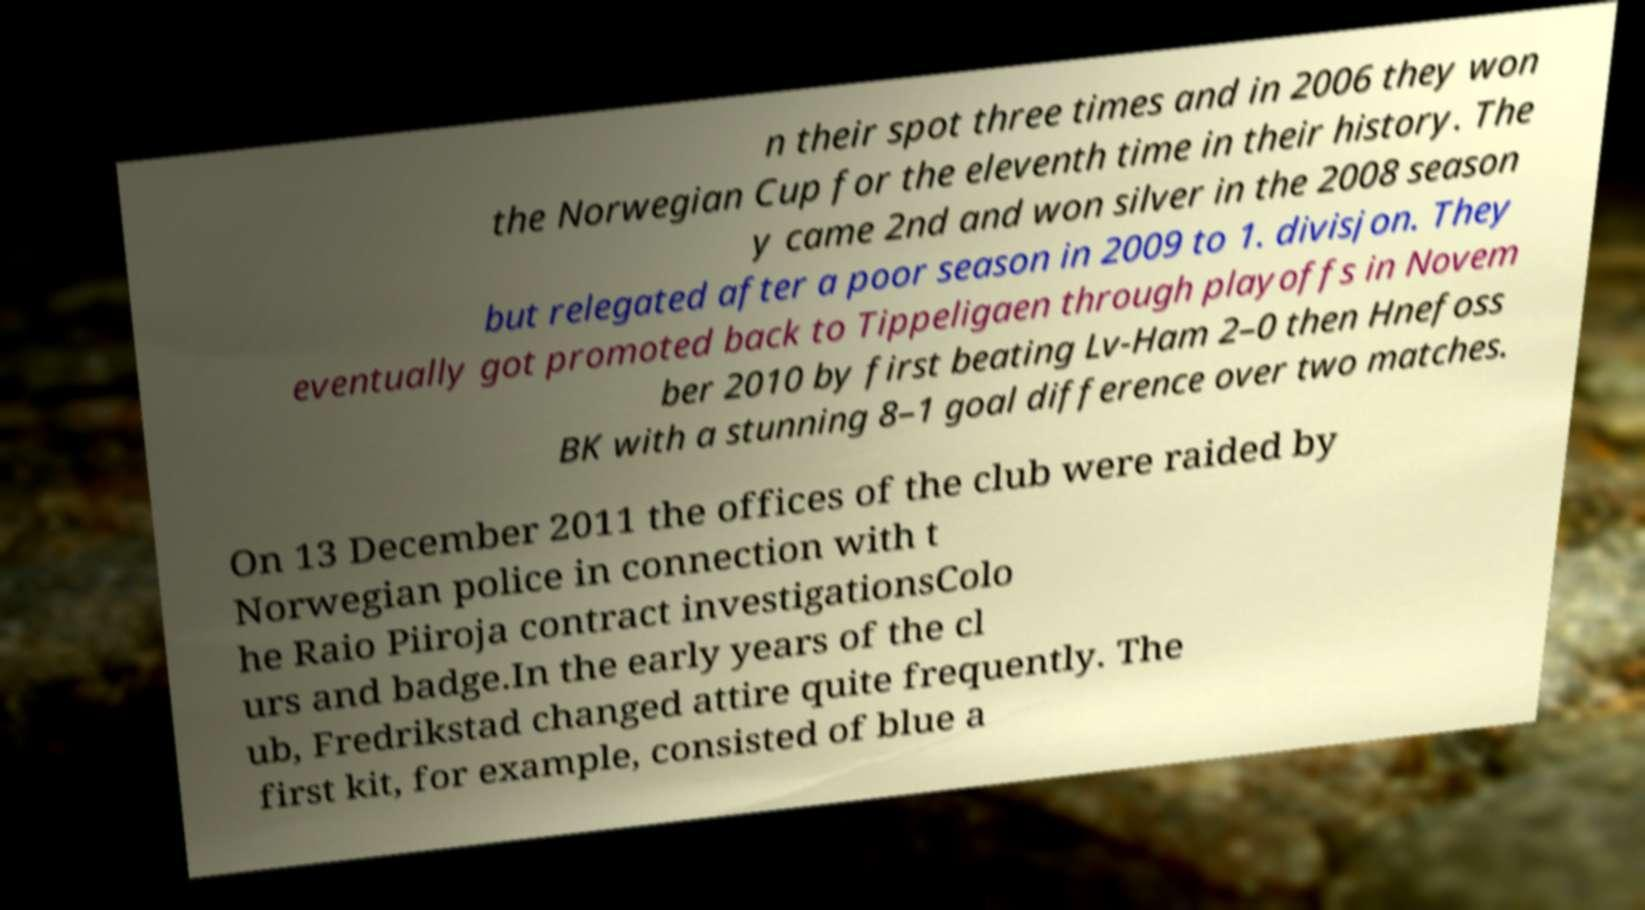Can you read and provide the text displayed in the image?This photo seems to have some interesting text. Can you extract and type it out for me? n their spot three times and in 2006 they won the Norwegian Cup for the eleventh time in their history. The y came 2nd and won silver in the 2008 season but relegated after a poor season in 2009 to 1. divisjon. They eventually got promoted back to Tippeligaen through playoffs in Novem ber 2010 by first beating Lv-Ham 2–0 then Hnefoss BK with a stunning 8–1 goal difference over two matches. On 13 December 2011 the offices of the club were raided by Norwegian police in connection with t he Raio Piiroja contract investigationsColo urs and badge.In the early years of the cl ub, Fredrikstad changed attire quite frequently. The first kit, for example, consisted of blue a 